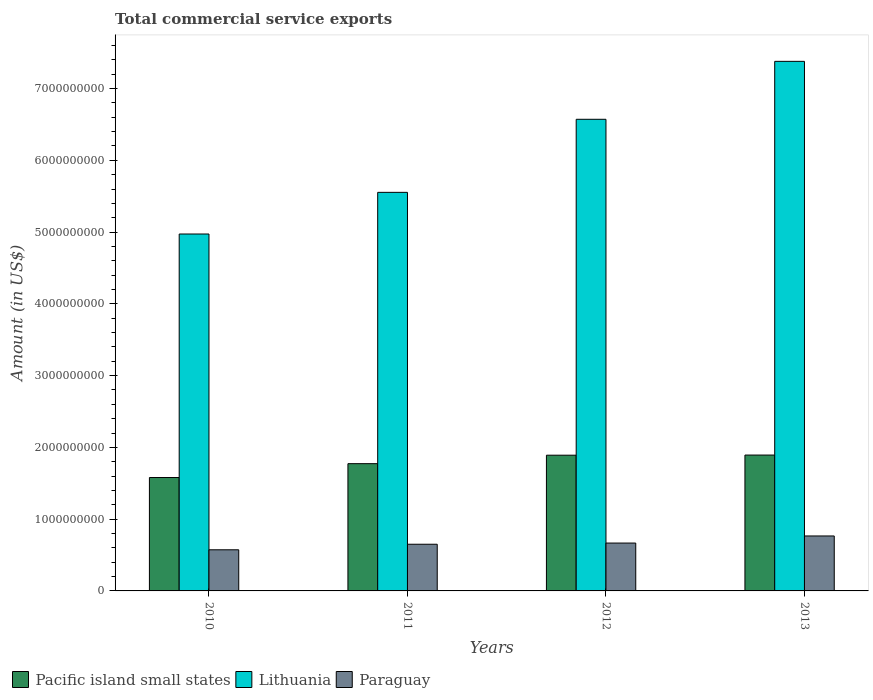How many groups of bars are there?
Your answer should be very brief. 4. What is the label of the 2nd group of bars from the left?
Your answer should be very brief. 2011. What is the total commercial service exports in Pacific island small states in 2011?
Provide a succinct answer. 1.77e+09. Across all years, what is the maximum total commercial service exports in Lithuania?
Make the answer very short. 7.38e+09. Across all years, what is the minimum total commercial service exports in Pacific island small states?
Provide a short and direct response. 1.58e+09. In which year was the total commercial service exports in Lithuania maximum?
Provide a short and direct response. 2013. In which year was the total commercial service exports in Lithuania minimum?
Provide a short and direct response. 2010. What is the total total commercial service exports in Lithuania in the graph?
Offer a terse response. 2.45e+1. What is the difference between the total commercial service exports in Paraguay in 2011 and that in 2012?
Your response must be concise. -1.67e+07. What is the difference between the total commercial service exports in Paraguay in 2012 and the total commercial service exports in Pacific island small states in 2013?
Your response must be concise. -1.23e+09. What is the average total commercial service exports in Paraguay per year?
Give a very brief answer. 6.64e+08. In the year 2012, what is the difference between the total commercial service exports in Pacific island small states and total commercial service exports in Lithuania?
Your answer should be very brief. -4.68e+09. In how many years, is the total commercial service exports in Pacific island small states greater than 4800000000 US$?
Offer a terse response. 0. What is the ratio of the total commercial service exports in Paraguay in 2010 to that in 2011?
Your answer should be compact. 0.88. Is the total commercial service exports in Lithuania in 2011 less than that in 2013?
Your answer should be compact. Yes. Is the difference between the total commercial service exports in Pacific island small states in 2011 and 2013 greater than the difference between the total commercial service exports in Lithuania in 2011 and 2013?
Your answer should be compact. Yes. What is the difference between the highest and the second highest total commercial service exports in Pacific island small states?
Provide a succinct answer. 2.06e+06. What is the difference between the highest and the lowest total commercial service exports in Paraguay?
Keep it short and to the point. 1.93e+08. What does the 2nd bar from the left in 2012 represents?
Your response must be concise. Lithuania. What does the 2nd bar from the right in 2011 represents?
Your answer should be compact. Lithuania. Is it the case that in every year, the sum of the total commercial service exports in Lithuania and total commercial service exports in Paraguay is greater than the total commercial service exports in Pacific island small states?
Provide a short and direct response. Yes. How many bars are there?
Your answer should be very brief. 12. Are all the bars in the graph horizontal?
Your answer should be compact. No. How many years are there in the graph?
Your response must be concise. 4. What is the difference between two consecutive major ticks on the Y-axis?
Ensure brevity in your answer.  1.00e+09. Are the values on the major ticks of Y-axis written in scientific E-notation?
Give a very brief answer. No. Where does the legend appear in the graph?
Ensure brevity in your answer.  Bottom left. How many legend labels are there?
Your response must be concise. 3. How are the legend labels stacked?
Provide a succinct answer. Horizontal. What is the title of the graph?
Your answer should be very brief. Total commercial service exports. What is the label or title of the X-axis?
Make the answer very short. Years. What is the label or title of the Y-axis?
Keep it short and to the point. Amount (in US$). What is the Amount (in US$) of Pacific island small states in 2010?
Your response must be concise. 1.58e+09. What is the Amount (in US$) of Lithuania in 2010?
Keep it short and to the point. 4.97e+09. What is the Amount (in US$) in Paraguay in 2010?
Offer a terse response. 5.73e+08. What is the Amount (in US$) in Pacific island small states in 2011?
Make the answer very short. 1.77e+09. What is the Amount (in US$) in Lithuania in 2011?
Your answer should be very brief. 5.55e+09. What is the Amount (in US$) in Paraguay in 2011?
Keep it short and to the point. 6.50e+08. What is the Amount (in US$) in Pacific island small states in 2012?
Your answer should be compact. 1.89e+09. What is the Amount (in US$) in Lithuania in 2012?
Your answer should be compact. 6.57e+09. What is the Amount (in US$) in Paraguay in 2012?
Your answer should be compact. 6.67e+08. What is the Amount (in US$) in Pacific island small states in 2013?
Offer a terse response. 1.89e+09. What is the Amount (in US$) of Lithuania in 2013?
Provide a succinct answer. 7.38e+09. What is the Amount (in US$) of Paraguay in 2013?
Offer a very short reply. 7.66e+08. Across all years, what is the maximum Amount (in US$) of Pacific island small states?
Your response must be concise. 1.89e+09. Across all years, what is the maximum Amount (in US$) of Lithuania?
Your answer should be compact. 7.38e+09. Across all years, what is the maximum Amount (in US$) in Paraguay?
Provide a succinct answer. 7.66e+08. Across all years, what is the minimum Amount (in US$) in Pacific island small states?
Provide a succinct answer. 1.58e+09. Across all years, what is the minimum Amount (in US$) in Lithuania?
Give a very brief answer. 4.97e+09. Across all years, what is the minimum Amount (in US$) of Paraguay?
Ensure brevity in your answer.  5.73e+08. What is the total Amount (in US$) in Pacific island small states in the graph?
Make the answer very short. 7.14e+09. What is the total Amount (in US$) in Lithuania in the graph?
Ensure brevity in your answer.  2.45e+1. What is the total Amount (in US$) of Paraguay in the graph?
Provide a short and direct response. 2.66e+09. What is the difference between the Amount (in US$) of Pacific island small states in 2010 and that in 2011?
Provide a succinct answer. -1.93e+08. What is the difference between the Amount (in US$) of Lithuania in 2010 and that in 2011?
Offer a very short reply. -5.80e+08. What is the difference between the Amount (in US$) in Paraguay in 2010 and that in 2011?
Your response must be concise. -7.72e+07. What is the difference between the Amount (in US$) in Pacific island small states in 2010 and that in 2012?
Give a very brief answer. -3.11e+08. What is the difference between the Amount (in US$) in Lithuania in 2010 and that in 2012?
Offer a very short reply. -1.60e+09. What is the difference between the Amount (in US$) in Paraguay in 2010 and that in 2012?
Your response must be concise. -9.39e+07. What is the difference between the Amount (in US$) in Pacific island small states in 2010 and that in 2013?
Give a very brief answer. -3.13e+08. What is the difference between the Amount (in US$) of Lithuania in 2010 and that in 2013?
Keep it short and to the point. -2.41e+09. What is the difference between the Amount (in US$) in Paraguay in 2010 and that in 2013?
Your answer should be compact. -1.93e+08. What is the difference between the Amount (in US$) in Pacific island small states in 2011 and that in 2012?
Your answer should be very brief. -1.18e+08. What is the difference between the Amount (in US$) in Lithuania in 2011 and that in 2012?
Provide a short and direct response. -1.02e+09. What is the difference between the Amount (in US$) of Paraguay in 2011 and that in 2012?
Give a very brief answer. -1.67e+07. What is the difference between the Amount (in US$) of Pacific island small states in 2011 and that in 2013?
Keep it short and to the point. -1.20e+08. What is the difference between the Amount (in US$) in Lithuania in 2011 and that in 2013?
Offer a terse response. -1.83e+09. What is the difference between the Amount (in US$) of Paraguay in 2011 and that in 2013?
Your response must be concise. -1.15e+08. What is the difference between the Amount (in US$) in Pacific island small states in 2012 and that in 2013?
Your response must be concise. -2.06e+06. What is the difference between the Amount (in US$) in Lithuania in 2012 and that in 2013?
Ensure brevity in your answer.  -8.07e+08. What is the difference between the Amount (in US$) in Paraguay in 2012 and that in 2013?
Give a very brief answer. -9.87e+07. What is the difference between the Amount (in US$) of Pacific island small states in 2010 and the Amount (in US$) of Lithuania in 2011?
Your response must be concise. -3.97e+09. What is the difference between the Amount (in US$) of Pacific island small states in 2010 and the Amount (in US$) of Paraguay in 2011?
Ensure brevity in your answer.  9.30e+08. What is the difference between the Amount (in US$) in Lithuania in 2010 and the Amount (in US$) in Paraguay in 2011?
Keep it short and to the point. 4.32e+09. What is the difference between the Amount (in US$) in Pacific island small states in 2010 and the Amount (in US$) in Lithuania in 2012?
Keep it short and to the point. -4.99e+09. What is the difference between the Amount (in US$) in Pacific island small states in 2010 and the Amount (in US$) in Paraguay in 2012?
Provide a short and direct response. 9.13e+08. What is the difference between the Amount (in US$) in Lithuania in 2010 and the Amount (in US$) in Paraguay in 2012?
Keep it short and to the point. 4.31e+09. What is the difference between the Amount (in US$) in Pacific island small states in 2010 and the Amount (in US$) in Lithuania in 2013?
Keep it short and to the point. -5.80e+09. What is the difference between the Amount (in US$) of Pacific island small states in 2010 and the Amount (in US$) of Paraguay in 2013?
Provide a short and direct response. 8.14e+08. What is the difference between the Amount (in US$) in Lithuania in 2010 and the Amount (in US$) in Paraguay in 2013?
Make the answer very short. 4.21e+09. What is the difference between the Amount (in US$) of Pacific island small states in 2011 and the Amount (in US$) of Lithuania in 2012?
Your response must be concise. -4.80e+09. What is the difference between the Amount (in US$) in Pacific island small states in 2011 and the Amount (in US$) in Paraguay in 2012?
Offer a very short reply. 1.11e+09. What is the difference between the Amount (in US$) in Lithuania in 2011 and the Amount (in US$) in Paraguay in 2012?
Your answer should be compact. 4.89e+09. What is the difference between the Amount (in US$) of Pacific island small states in 2011 and the Amount (in US$) of Lithuania in 2013?
Your response must be concise. -5.61e+09. What is the difference between the Amount (in US$) of Pacific island small states in 2011 and the Amount (in US$) of Paraguay in 2013?
Provide a short and direct response. 1.01e+09. What is the difference between the Amount (in US$) in Lithuania in 2011 and the Amount (in US$) in Paraguay in 2013?
Ensure brevity in your answer.  4.79e+09. What is the difference between the Amount (in US$) in Pacific island small states in 2012 and the Amount (in US$) in Lithuania in 2013?
Keep it short and to the point. -5.49e+09. What is the difference between the Amount (in US$) in Pacific island small states in 2012 and the Amount (in US$) in Paraguay in 2013?
Your answer should be compact. 1.13e+09. What is the difference between the Amount (in US$) in Lithuania in 2012 and the Amount (in US$) in Paraguay in 2013?
Your answer should be compact. 5.81e+09. What is the average Amount (in US$) in Pacific island small states per year?
Give a very brief answer. 1.78e+09. What is the average Amount (in US$) in Lithuania per year?
Provide a short and direct response. 6.12e+09. What is the average Amount (in US$) in Paraguay per year?
Your answer should be compact. 6.64e+08. In the year 2010, what is the difference between the Amount (in US$) in Pacific island small states and Amount (in US$) in Lithuania?
Ensure brevity in your answer.  -3.39e+09. In the year 2010, what is the difference between the Amount (in US$) in Pacific island small states and Amount (in US$) in Paraguay?
Keep it short and to the point. 1.01e+09. In the year 2010, what is the difference between the Amount (in US$) of Lithuania and Amount (in US$) of Paraguay?
Offer a terse response. 4.40e+09. In the year 2011, what is the difference between the Amount (in US$) in Pacific island small states and Amount (in US$) in Lithuania?
Give a very brief answer. -3.78e+09. In the year 2011, what is the difference between the Amount (in US$) of Pacific island small states and Amount (in US$) of Paraguay?
Provide a succinct answer. 1.12e+09. In the year 2011, what is the difference between the Amount (in US$) in Lithuania and Amount (in US$) in Paraguay?
Provide a short and direct response. 4.90e+09. In the year 2012, what is the difference between the Amount (in US$) in Pacific island small states and Amount (in US$) in Lithuania?
Your response must be concise. -4.68e+09. In the year 2012, what is the difference between the Amount (in US$) in Pacific island small states and Amount (in US$) in Paraguay?
Provide a short and direct response. 1.22e+09. In the year 2012, what is the difference between the Amount (in US$) of Lithuania and Amount (in US$) of Paraguay?
Give a very brief answer. 5.91e+09. In the year 2013, what is the difference between the Amount (in US$) in Pacific island small states and Amount (in US$) in Lithuania?
Keep it short and to the point. -5.49e+09. In the year 2013, what is the difference between the Amount (in US$) in Pacific island small states and Amount (in US$) in Paraguay?
Ensure brevity in your answer.  1.13e+09. In the year 2013, what is the difference between the Amount (in US$) in Lithuania and Amount (in US$) in Paraguay?
Give a very brief answer. 6.61e+09. What is the ratio of the Amount (in US$) of Pacific island small states in 2010 to that in 2011?
Provide a succinct answer. 0.89. What is the ratio of the Amount (in US$) in Lithuania in 2010 to that in 2011?
Provide a succinct answer. 0.9. What is the ratio of the Amount (in US$) of Paraguay in 2010 to that in 2011?
Offer a very short reply. 0.88. What is the ratio of the Amount (in US$) of Pacific island small states in 2010 to that in 2012?
Keep it short and to the point. 0.84. What is the ratio of the Amount (in US$) of Lithuania in 2010 to that in 2012?
Your answer should be very brief. 0.76. What is the ratio of the Amount (in US$) in Paraguay in 2010 to that in 2012?
Ensure brevity in your answer.  0.86. What is the ratio of the Amount (in US$) in Pacific island small states in 2010 to that in 2013?
Make the answer very short. 0.83. What is the ratio of the Amount (in US$) of Lithuania in 2010 to that in 2013?
Offer a very short reply. 0.67. What is the ratio of the Amount (in US$) of Paraguay in 2010 to that in 2013?
Offer a very short reply. 0.75. What is the ratio of the Amount (in US$) of Pacific island small states in 2011 to that in 2012?
Offer a very short reply. 0.94. What is the ratio of the Amount (in US$) of Lithuania in 2011 to that in 2012?
Ensure brevity in your answer.  0.85. What is the ratio of the Amount (in US$) of Paraguay in 2011 to that in 2012?
Your answer should be very brief. 0.97. What is the ratio of the Amount (in US$) in Pacific island small states in 2011 to that in 2013?
Provide a short and direct response. 0.94. What is the ratio of the Amount (in US$) in Lithuania in 2011 to that in 2013?
Ensure brevity in your answer.  0.75. What is the ratio of the Amount (in US$) in Paraguay in 2011 to that in 2013?
Keep it short and to the point. 0.85. What is the ratio of the Amount (in US$) of Lithuania in 2012 to that in 2013?
Make the answer very short. 0.89. What is the ratio of the Amount (in US$) of Paraguay in 2012 to that in 2013?
Give a very brief answer. 0.87. What is the difference between the highest and the second highest Amount (in US$) of Pacific island small states?
Give a very brief answer. 2.06e+06. What is the difference between the highest and the second highest Amount (in US$) in Lithuania?
Your answer should be very brief. 8.07e+08. What is the difference between the highest and the second highest Amount (in US$) in Paraguay?
Your answer should be compact. 9.87e+07. What is the difference between the highest and the lowest Amount (in US$) in Pacific island small states?
Provide a short and direct response. 3.13e+08. What is the difference between the highest and the lowest Amount (in US$) in Lithuania?
Provide a short and direct response. 2.41e+09. What is the difference between the highest and the lowest Amount (in US$) in Paraguay?
Your answer should be compact. 1.93e+08. 